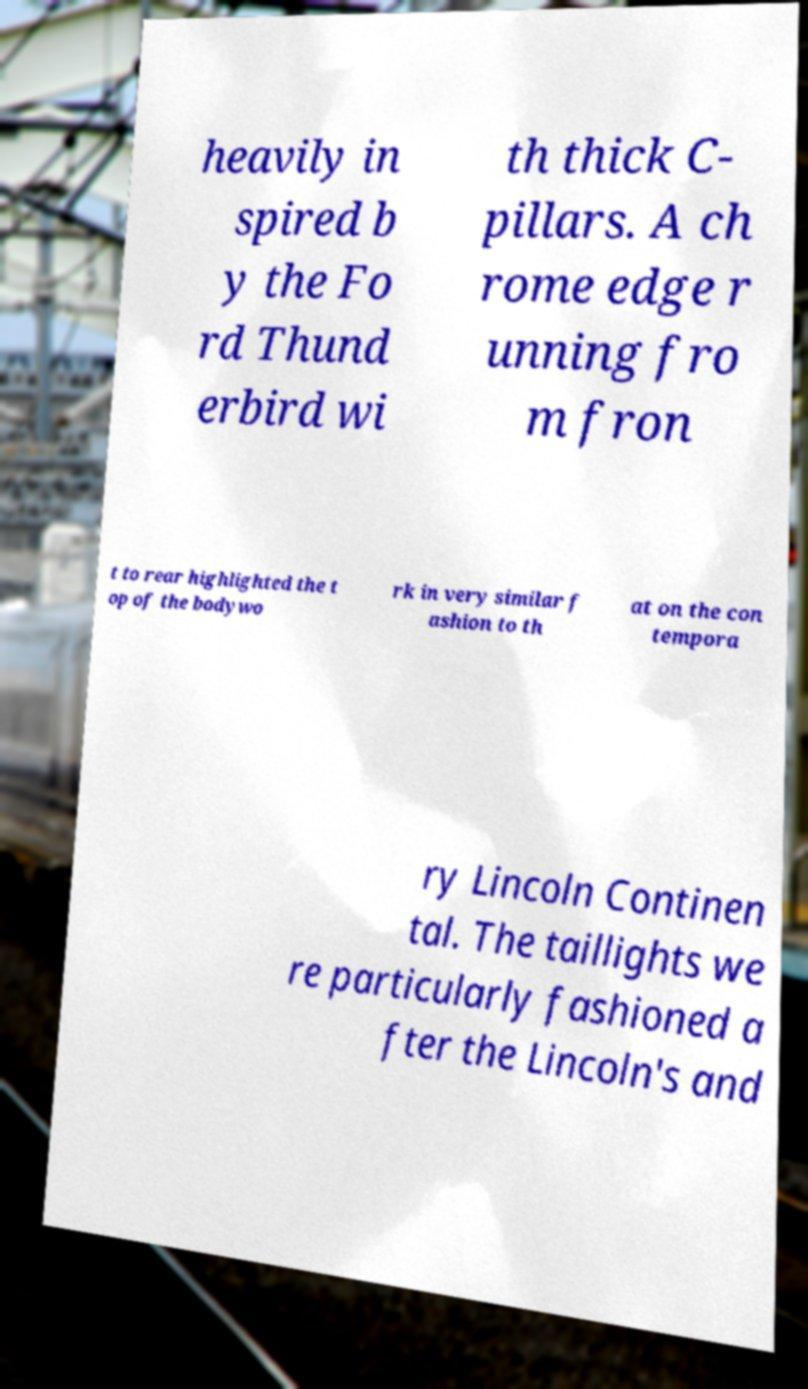There's text embedded in this image that I need extracted. Can you transcribe it verbatim? heavily in spired b y the Fo rd Thund erbird wi th thick C- pillars. A ch rome edge r unning fro m fron t to rear highlighted the t op of the bodywo rk in very similar f ashion to th at on the con tempora ry Lincoln Continen tal. The taillights we re particularly fashioned a fter the Lincoln's and 